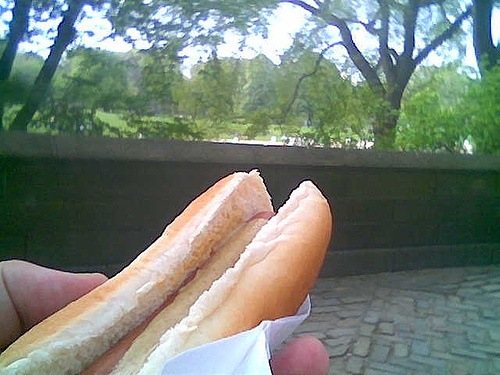Describe the objects in this image and their specific colors. I can see hot dog in white, lightgray, tan, and darkgray tones and people in white, gray, and darkgray tones in this image. 